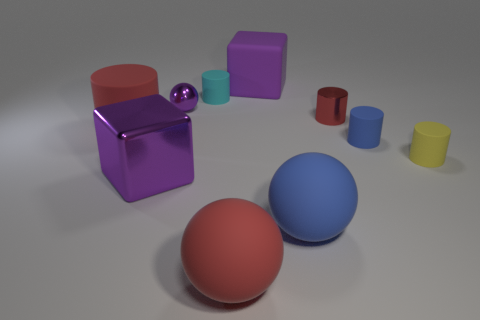Subtract 1 cylinders. How many cylinders are left? 4 Subtract all big cylinders. How many cylinders are left? 4 Subtract all blue cylinders. How many cylinders are left? 4 Subtract all blue cylinders. Subtract all green cubes. How many cylinders are left? 4 Subtract all blocks. How many objects are left? 8 Subtract 1 purple blocks. How many objects are left? 9 Subtract all tiny purple metallic blocks. Subtract all yellow cylinders. How many objects are left? 9 Add 9 tiny yellow objects. How many tiny yellow objects are left? 10 Add 8 red metallic things. How many red metallic things exist? 9 